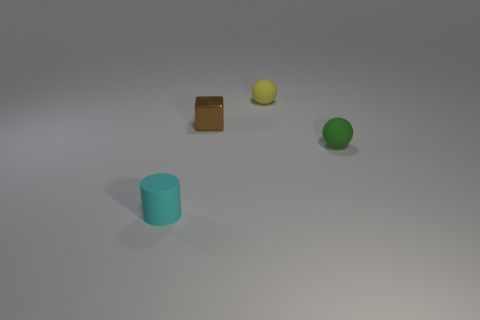Subtract all cubes. How many objects are left? 3 Subtract 0 cyan balls. How many objects are left? 4 Subtract all red spheres. Subtract all cyan cubes. How many spheres are left? 2 Subtract all cyan cylinders. How many yellow balls are left? 1 Subtract all tiny cyan matte objects. Subtract all green shiny cylinders. How many objects are left? 3 Add 1 brown metallic blocks. How many brown metallic blocks are left? 2 Add 1 tiny green rubber balls. How many tiny green rubber balls exist? 2 Add 1 small spheres. How many objects exist? 5 